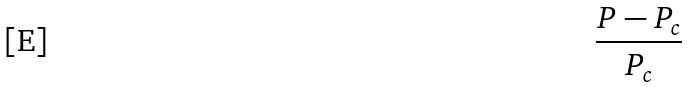Convert formula to latex. <formula><loc_0><loc_0><loc_500><loc_500>\frac { P - P _ { c } } { P _ { c } }</formula> 